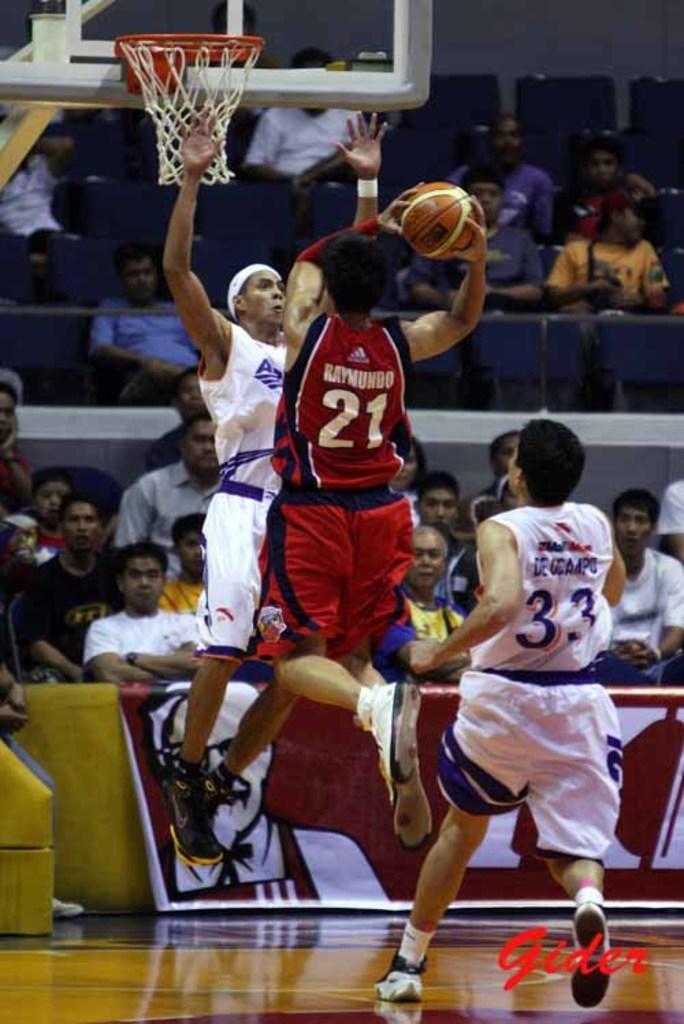Could you give a brief overview of what you see in this image? In the center of the image we can see two persons are jumping and one person is running and they are in different costumes. Among them, we see one person is holding a ball. At the bottom right side of the image, we can see some text. In the background we can see fences, one banner, few people are sitting, few people are wearing some objects and a few other objects. At the top of the image we can see one baseball ring with net and a few other objects. 